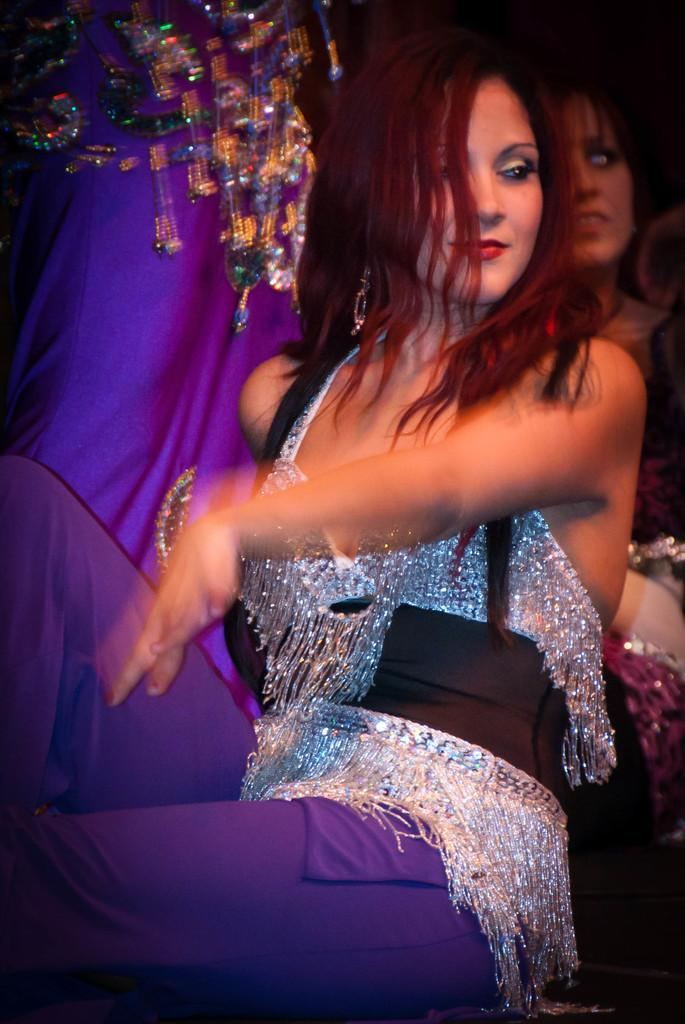What is the main subject of the image? The main subject of the image is a woman. Can you describe what the woman is wearing? The woman is wearing clothes. Are there any other people visible in the image? Yes, there are other people visible in the image. What type of mint can be seen growing in the image? There is no mint plant present in the image. How does the man in the image react to the woman's presence? There is no man present in the image; only the woman and other people are visible. 